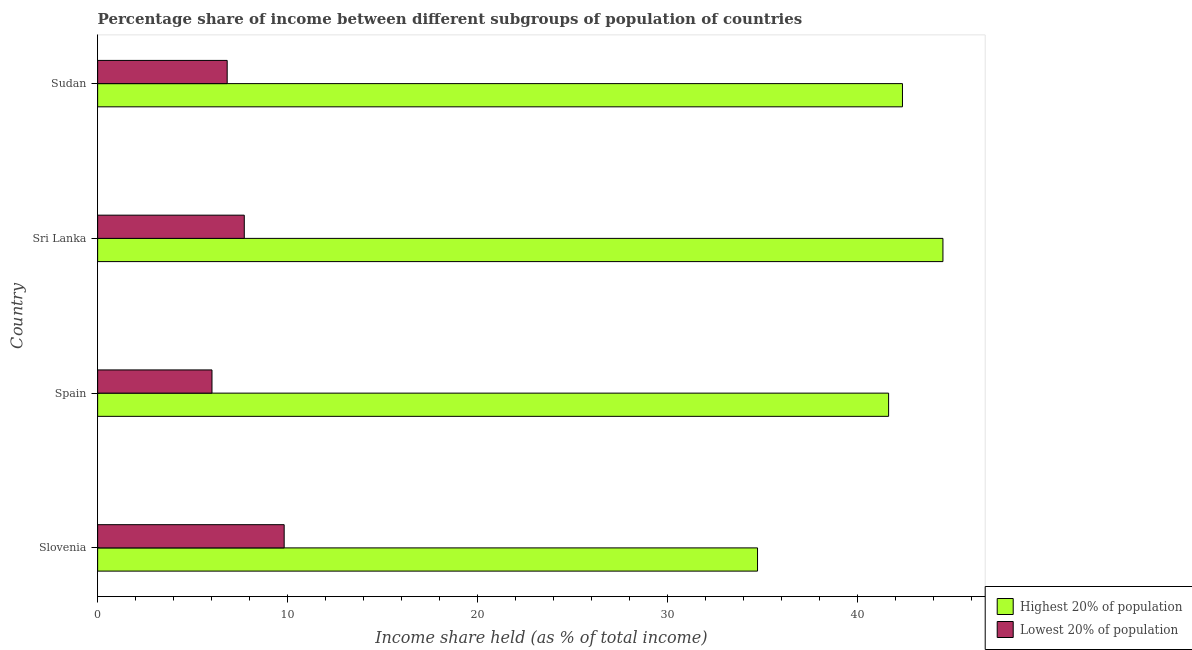How many groups of bars are there?
Keep it short and to the point. 4. Are the number of bars on each tick of the Y-axis equal?
Offer a terse response. Yes. How many bars are there on the 2nd tick from the bottom?
Make the answer very short. 2. What is the label of the 1st group of bars from the top?
Your answer should be compact. Sudan. In how many cases, is the number of bars for a given country not equal to the number of legend labels?
Ensure brevity in your answer.  0. What is the income share held by lowest 20% of the population in Slovenia?
Offer a terse response. 9.82. Across all countries, what is the maximum income share held by highest 20% of the population?
Give a very brief answer. 44.5. Across all countries, what is the minimum income share held by highest 20% of the population?
Keep it short and to the point. 34.74. In which country was the income share held by lowest 20% of the population maximum?
Keep it short and to the point. Slovenia. In which country was the income share held by highest 20% of the population minimum?
Provide a short and direct response. Slovenia. What is the total income share held by highest 20% of the population in the graph?
Ensure brevity in your answer.  163.25. What is the difference between the income share held by highest 20% of the population in Spain and that in Sri Lanka?
Provide a short and direct response. -2.86. What is the difference between the income share held by lowest 20% of the population in Sri Lanka and the income share held by highest 20% of the population in Spain?
Your answer should be very brief. -33.92. What is the average income share held by highest 20% of the population per country?
Make the answer very short. 40.81. What is the difference between the income share held by lowest 20% of the population and income share held by highest 20% of the population in Slovenia?
Give a very brief answer. -24.92. What is the ratio of the income share held by lowest 20% of the population in Slovenia to that in Sri Lanka?
Provide a succinct answer. 1.27. Is the difference between the income share held by highest 20% of the population in Slovenia and Sri Lanka greater than the difference between the income share held by lowest 20% of the population in Slovenia and Sri Lanka?
Provide a succinct answer. No. What is the difference between the highest and the second highest income share held by highest 20% of the population?
Offer a terse response. 2.13. Is the sum of the income share held by lowest 20% of the population in Spain and Sri Lanka greater than the maximum income share held by highest 20% of the population across all countries?
Give a very brief answer. No. What does the 2nd bar from the top in Sri Lanka represents?
Your response must be concise. Highest 20% of population. What does the 1st bar from the bottom in Spain represents?
Offer a very short reply. Highest 20% of population. How many bars are there?
Ensure brevity in your answer.  8. Are all the bars in the graph horizontal?
Keep it short and to the point. Yes. How many legend labels are there?
Your response must be concise. 2. How are the legend labels stacked?
Offer a very short reply. Vertical. What is the title of the graph?
Your response must be concise. Percentage share of income between different subgroups of population of countries. Does "UN agencies" appear as one of the legend labels in the graph?
Your response must be concise. No. What is the label or title of the X-axis?
Keep it short and to the point. Income share held (as % of total income). What is the Income share held (as % of total income) of Highest 20% of population in Slovenia?
Your answer should be compact. 34.74. What is the Income share held (as % of total income) of Lowest 20% of population in Slovenia?
Keep it short and to the point. 9.82. What is the Income share held (as % of total income) of Highest 20% of population in Spain?
Your answer should be very brief. 41.64. What is the Income share held (as % of total income) in Lowest 20% of population in Spain?
Give a very brief answer. 6.02. What is the Income share held (as % of total income) in Highest 20% of population in Sri Lanka?
Make the answer very short. 44.5. What is the Income share held (as % of total income) of Lowest 20% of population in Sri Lanka?
Your answer should be very brief. 7.72. What is the Income share held (as % of total income) of Highest 20% of population in Sudan?
Your response must be concise. 42.37. What is the Income share held (as % of total income) of Lowest 20% of population in Sudan?
Ensure brevity in your answer.  6.82. Across all countries, what is the maximum Income share held (as % of total income) in Highest 20% of population?
Provide a succinct answer. 44.5. Across all countries, what is the maximum Income share held (as % of total income) of Lowest 20% of population?
Give a very brief answer. 9.82. Across all countries, what is the minimum Income share held (as % of total income) in Highest 20% of population?
Your response must be concise. 34.74. Across all countries, what is the minimum Income share held (as % of total income) in Lowest 20% of population?
Offer a very short reply. 6.02. What is the total Income share held (as % of total income) in Highest 20% of population in the graph?
Provide a short and direct response. 163.25. What is the total Income share held (as % of total income) in Lowest 20% of population in the graph?
Your response must be concise. 30.38. What is the difference between the Income share held (as % of total income) of Highest 20% of population in Slovenia and that in Spain?
Keep it short and to the point. -6.9. What is the difference between the Income share held (as % of total income) in Lowest 20% of population in Slovenia and that in Spain?
Offer a terse response. 3.8. What is the difference between the Income share held (as % of total income) of Highest 20% of population in Slovenia and that in Sri Lanka?
Keep it short and to the point. -9.76. What is the difference between the Income share held (as % of total income) in Highest 20% of population in Slovenia and that in Sudan?
Your answer should be compact. -7.63. What is the difference between the Income share held (as % of total income) of Highest 20% of population in Spain and that in Sri Lanka?
Offer a terse response. -2.86. What is the difference between the Income share held (as % of total income) of Lowest 20% of population in Spain and that in Sri Lanka?
Ensure brevity in your answer.  -1.7. What is the difference between the Income share held (as % of total income) of Highest 20% of population in Spain and that in Sudan?
Your answer should be compact. -0.73. What is the difference between the Income share held (as % of total income) of Lowest 20% of population in Spain and that in Sudan?
Give a very brief answer. -0.8. What is the difference between the Income share held (as % of total income) in Highest 20% of population in Sri Lanka and that in Sudan?
Offer a very short reply. 2.13. What is the difference between the Income share held (as % of total income) in Lowest 20% of population in Sri Lanka and that in Sudan?
Keep it short and to the point. 0.9. What is the difference between the Income share held (as % of total income) in Highest 20% of population in Slovenia and the Income share held (as % of total income) in Lowest 20% of population in Spain?
Offer a very short reply. 28.72. What is the difference between the Income share held (as % of total income) of Highest 20% of population in Slovenia and the Income share held (as % of total income) of Lowest 20% of population in Sri Lanka?
Offer a very short reply. 27.02. What is the difference between the Income share held (as % of total income) of Highest 20% of population in Slovenia and the Income share held (as % of total income) of Lowest 20% of population in Sudan?
Give a very brief answer. 27.92. What is the difference between the Income share held (as % of total income) in Highest 20% of population in Spain and the Income share held (as % of total income) in Lowest 20% of population in Sri Lanka?
Your response must be concise. 33.92. What is the difference between the Income share held (as % of total income) in Highest 20% of population in Spain and the Income share held (as % of total income) in Lowest 20% of population in Sudan?
Your response must be concise. 34.82. What is the difference between the Income share held (as % of total income) in Highest 20% of population in Sri Lanka and the Income share held (as % of total income) in Lowest 20% of population in Sudan?
Provide a succinct answer. 37.68. What is the average Income share held (as % of total income) of Highest 20% of population per country?
Give a very brief answer. 40.81. What is the average Income share held (as % of total income) in Lowest 20% of population per country?
Keep it short and to the point. 7.59. What is the difference between the Income share held (as % of total income) of Highest 20% of population and Income share held (as % of total income) of Lowest 20% of population in Slovenia?
Provide a short and direct response. 24.92. What is the difference between the Income share held (as % of total income) in Highest 20% of population and Income share held (as % of total income) in Lowest 20% of population in Spain?
Ensure brevity in your answer.  35.62. What is the difference between the Income share held (as % of total income) of Highest 20% of population and Income share held (as % of total income) of Lowest 20% of population in Sri Lanka?
Offer a terse response. 36.78. What is the difference between the Income share held (as % of total income) in Highest 20% of population and Income share held (as % of total income) in Lowest 20% of population in Sudan?
Provide a succinct answer. 35.55. What is the ratio of the Income share held (as % of total income) of Highest 20% of population in Slovenia to that in Spain?
Keep it short and to the point. 0.83. What is the ratio of the Income share held (as % of total income) in Lowest 20% of population in Slovenia to that in Spain?
Your response must be concise. 1.63. What is the ratio of the Income share held (as % of total income) in Highest 20% of population in Slovenia to that in Sri Lanka?
Your answer should be very brief. 0.78. What is the ratio of the Income share held (as % of total income) in Lowest 20% of population in Slovenia to that in Sri Lanka?
Your answer should be very brief. 1.27. What is the ratio of the Income share held (as % of total income) in Highest 20% of population in Slovenia to that in Sudan?
Your response must be concise. 0.82. What is the ratio of the Income share held (as % of total income) in Lowest 20% of population in Slovenia to that in Sudan?
Keep it short and to the point. 1.44. What is the ratio of the Income share held (as % of total income) in Highest 20% of population in Spain to that in Sri Lanka?
Your answer should be compact. 0.94. What is the ratio of the Income share held (as % of total income) in Lowest 20% of population in Spain to that in Sri Lanka?
Make the answer very short. 0.78. What is the ratio of the Income share held (as % of total income) in Highest 20% of population in Spain to that in Sudan?
Offer a terse response. 0.98. What is the ratio of the Income share held (as % of total income) of Lowest 20% of population in Spain to that in Sudan?
Provide a succinct answer. 0.88. What is the ratio of the Income share held (as % of total income) of Highest 20% of population in Sri Lanka to that in Sudan?
Offer a terse response. 1.05. What is the ratio of the Income share held (as % of total income) in Lowest 20% of population in Sri Lanka to that in Sudan?
Keep it short and to the point. 1.13. What is the difference between the highest and the second highest Income share held (as % of total income) in Highest 20% of population?
Your response must be concise. 2.13. What is the difference between the highest and the lowest Income share held (as % of total income) in Highest 20% of population?
Your answer should be very brief. 9.76. 